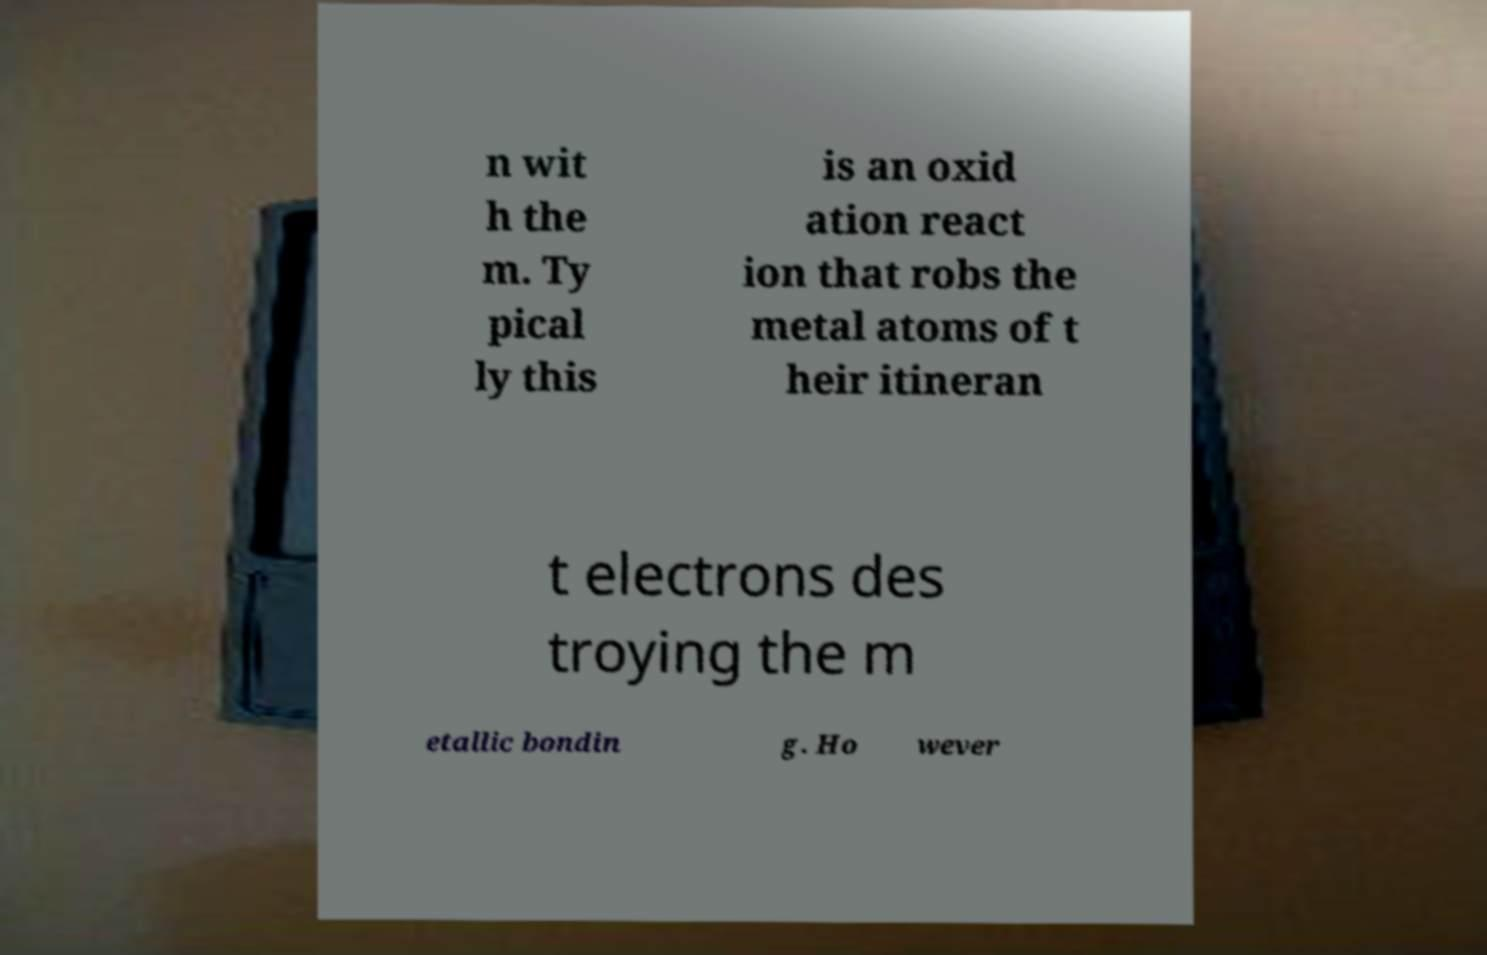Can you accurately transcribe the text from the provided image for me? n wit h the m. Ty pical ly this is an oxid ation react ion that robs the metal atoms of t heir itineran t electrons des troying the m etallic bondin g. Ho wever 